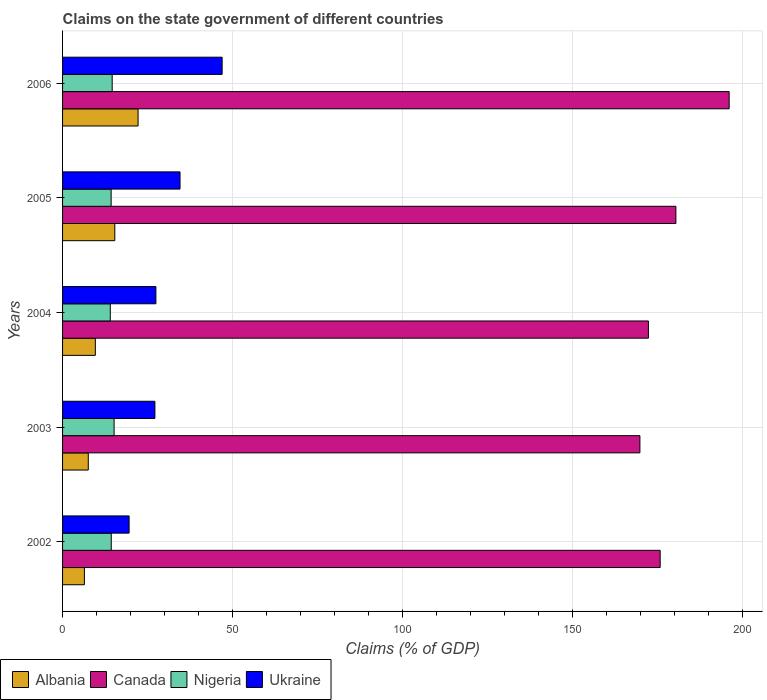How many different coloured bars are there?
Provide a short and direct response. 4. How many groups of bars are there?
Make the answer very short. 5. Are the number of bars on each tick of the Y-axis equal?
Give a very brief answer. Yes. How many bars are there on the 5th tick from the bottom?
Your answer should be very brief. 4. What is the percentage of GDP claimed on the state government in Nigeria in 2005?
Your answer should be compact. 14.28. Across all years, what is the maximum percentage of GDP claimed on the state government in Nigeria?
Provide a short and direct response. 15.15. Across all years, what is the minimum percentage of GDP claimed on the state government in Albania?
Offer a very short reply. 6.42. In which year was the percentage of GDP claimed on the state government in Nigeria minimum?
Offer a very short reply. 2004. What is the total percentage of GDP claimed on the state government in Albania in the graph?
Your answer should be compact. 61.2. What is the difference between the percentage of GDP claimed on the state government in Canada in 2005 and that in 2006?
Your answer should be compact. -15.67. What is the difference between the percentage of GDP claimed on the state government in Ukraine in 2006 and the percentage of GDP claimed on the state government in Nigeria in 2002?
Offer a terse response. 32.61. What is the average percentage of GDP claimed on the state government in Nigeria per year?
Keep it short and to the point. 14.48. In the year 2006, what is the difference between the percentage of GDP claimed on the state government in Canada and percentage of GDP claimed on the state government in Albania?
Ensure brevity in your answer.  173.85. What is the ratio of the percentage of GDP claimed on the state government in Canada in 2005 to that in 2006?
Offer a terse response. 0.92. Is the percentage of GDP claimed on the state government in Canada in 2004 less than that in 2006?
Offer a terse response. Yes. What is the difference between the highest and the second highest percentage of GDP claimed on the state government in Canada?
Ensure brevity in your answer.  15.67. What is the difference between the highest and the lowest percentage of GDP claimed on the state government in Ukraine?
Offer a terse response. 27.36. Is the sum of the percentage of GDP claimed on the state government in Ukraine in 2002 and 2003 greater than the maximum percentage of GDP claimed on the state government in Canada across all years?
Make the answer very short. No. What does the 2nd bar from the top in 2005 represents?
Give a very brief answer. Nigeria. What does the 1st bar from the bottom in 2006 represents?
Your answer should be very brief. Albania. How many bars are there?
Offer a terse response. 20. How many years are there in the graph?
Provide a short and direct response. 5. What is the difference between two consecutive major ticks on the X-axis?
Ensure brevity in your answer.  50. Are the values on the major ticks of X-axis written in scientific E-notation?
Your response must be concise. No. Does the graph contain grids?
Ensure brevity in your answer.  Yes. How many legend labels are there?
Your answer should be compact. 4. How are the legend labels stacked?
Your answer should be compact. Horizontal. What is the title of the graph?
Make the answer very short. Claims on the state government of different countries. What is the label or title of the X-axis?
Your answer should be very brief. Claims (% of GDP). What is the Claims (% of GDP) of Albania in 2002?
Offer a very short reply. 6.42. What is the Claims (% of GDP) in Canada in 2002?
Your response must be concise. 175.77. What is the Claims (% of GDP) in Nigeria in 2002?
Your answer should be very brief. 14.32. What is the Claims (% of GDP) in Ukraine in 2002?
Offer a very short reply. 19.57. What is the Claims (% of GDP) in Albania in 2003?
Keep it short and to the point. 7.56. What is the Claims (% of GDP) of Canada in 2003?
Keep it short and to the point. 169.81. What is the Claims (% of GDP) of Nigeria in 2003?
Provide a succinct answer. 15.15. What is the Claims (% of GDP) of Ukraine in 2003?
Offer a terse response. 27.16. What is the Claims (% of GDP) in Albania in 2004?
Your answer should be very brief. 9.64. What is the Claims (% of GDP) in Canada in 2004?
Ensure brevity in your answer.  172.31. What is the Claims (% of GDP) of Nigeria in 2004?
Ensure brevity in your answer.  14.03. What is the Claims (% of GDP) of Ukraine in 2004?
Provide a succinct answer. 27.45. What is the Claims (% of GDP) of Albania in 2005?
Provide a short and direct response. 15.36. What is the Claims (% of GDP) of Canada in 2005?
Make the answer very short. 180.39. What is the Claims (% of GDP) in Nigeria in 2005?
Offer a terse response. 14.28. What is the Claims (% of GDP) in Ukraine in 2005?
Offer a terse response. 34.55. What is the Claims (% of GDP) in Albania in 2006?
Provide a short and direct response. 22.21. What is the Claims (% of GDP) in Canada in 2006?
Provide a succinct answer. 196.06. What is the Claims (% of GDP) in Nigeria in 2006?
Keep it short and to the point. 14.59. What is the Claims (% of GDP) of Ukraine in 2006?
Provide a succinct answer. 46.93. Across all years, what is the maximum Claims (% of GDP) in Albania?
Make the answer very short. 22.21. Across all years, what is the maximum Claims (% of GDP) of Canada?
Make the answer very short. 196.06. Across all years, what is the maximum Claims (% of GDP) of Nigeria?
Offer a terse response. 15.15. Across all years, what is the maximum Claims (% of GDP) of Ukraine?
Provide a short and direct response. 46.93. Across all years, what is the minimum Claims (% of GDP) of Albania?
Provide a short and direct response. 6.42. Across all years, what is the minimum Claims (% of GDP) in Canada?
Your answer should be compact. 169.81. Across all years, what is the minimum Claims (% of GDP) of Nigeria?
Your response must be concise. 14.03. Across all years, what is the minimum Claims (% of GDP) of Ukraine?
Offer a very short reply. 19.57. What is the total Claims (% of GDP) in Albania in the graph?
Give a very brief answer. 61.2. What is the total Claims (% of GDP) of Canada in the graph?
Give a very brief answer. 894.34. What is the total Claims (% of GDP) in Nigeria in the graph?
Your response must be concise. 72.39. What is the total Claims (% of GDP) of Ukraine in the graph?
Make the answer very short. 155.67. What is the difference between the Claims (% of GDP) of Albania in 2002 and that in 2003?
Provide a succinct answer. -1.14. What is the difference between the Claims (% of GDP) of Canada in 2002 and that in 2003?
Offer a terse response. 5.96. What is the difference between the Claims (% of GDP) in Nigeria in 2002 and that in 2003?
Offer a terse response. -0.83. What is the difference between the Claims (% of GDP) in Ukraine in 2002 and that in 2003?
Provide a succinct answer. -7.59. What is the difference between the Claims (% of GDP) of Albania in 2002 and that in 2004?
Give a very brief answer. -3.21. What is the difference between the Claims (% of GDP) in Canada in 2002 and that in 2004?
Ensure brevity in your answer.  3.46. What is the difference between the Claims (% of GDP) of Nigeria in 2002 and that in 2004?
Give a very brief answer. 0.29. What is the difference between the Claims (% of GDP) of Ukraine in 2002 and that in 2004?
Provide a short and direct response. -7.88. What is the difference between the Claims (% of GDP) of Albania in 2002 and that in 2005?
Give a very brief answer. -8.94. What is the difference between the Claims (% of GDP) in Canada in 2002 and that in 2005?
Keep it short and to the point. -4.63. What is the difference between the Claims (% of GDP) of Nigeria in 2002 and that in 2005?
Ensure brevity in your answer.  0.04. What is the difference between the Claims (% of GDP) in Ukraine in 2002 and that in 2005?
Make the answer very short. -14.98. What is the difference between the Claims (% of GDP) in Albania in 2002 and that in 2006?
Offer a terse response. -15.79. What is the difference between the Claims (% of GDP) in Canada in 2002 and that in 2006?
Make the answer very short. -20.29. What is the difference between the Claims (% of GDP) in Nigeria in 2002 and that in 2006?
Your answer should be very brief. -0.27. What is the difference between the Claims (% of GDP) in Ukraine in 2002 and that in 2006?
Give a very brief answer. -27.36. What is the difference between the Claims (% of GDP) in Albania in 2003 and that in 2004?
Give a very brief answer. -2.08. What is the difference between the Claims (% of GDP) in Canada in 2003 and that in 2004?
Provide a succinct answer. -2.51. What is the difference between the Claims (% of GDP) in Nigeria in 2003 and that in 2004?
Your answer should be compact. 1.12. What is the difference between the Claims (% of GDP) of Ukraine in 2003 and that in 2004?
Offer a very short reply. -0.29. What is the difference between the Claims (% of GDP) in Albania in 2003 and that in 2005?
Provide a succinct answer. -7.8. What is the difference between the Claims (% of GDP) of Canada in 2003 and that in 2005?
Provide a succinct answer. -10.59. What is the difference between the Claims (% of GDP) of Nigeria in 2003 and that in 2005?
Offer a terse response. 0.87. What is the difference between the Claims (% of GDP) of Ukraine in 2003 and that in 2005?
Provide a short and direct response. -7.39. What is the difference between the Claims (% of GDP) of Albania in 2003 and that in 2006?
Provide a succinct answer. -14.65. What is the difference between the Claims (% of GDP) of Canada in 2003 and that in 2006?
Your answer should be compact. -26.25. What is the difference between the Claims (% of GDP) in Nigeria in 2003 and that in 2006?
Give a very brief answer. 0.56. What is the difference between the Claims (% of GDP) of Ukraine in 2003 and that in 2006?
Provide a succinct answer. -19.77. What is the difference between the Claims (% of GDP) in Albania in 2004 and that in 2005?
Your response must be concise. -5.72. What is the difference between the Claims (% of GDP) in Canada in 2004 and that in 2005?
Ensure brevity in your answer.  -8.08. What is the difference between the Claims (% of GDP) of Nigeria in 2004 and that in 2005?
Ensure brevity in your answer.  -0.25. What is the difference between the Claims (% of GDP) of Ukraine in 2004 and that in 2005?
Offer a very short reply. -7.1. What is the difference between the Claims (% of GDP) of Albania in 2004 and that in 2006?
Provide a succinct answer. -12.57. What is the difference between the Claims (% of GDP) of Canada in 2004 and that in 2006?
Your answer should be compact. -23.75. What is the difference between the Claims (% of GDP) of Nigeria in 2004 and that in 2006?
Ensure brevity in your answer.  -0.56. What is the difference between the Claims (% of GDP) in Ukraine in 2004 and that in 2006?
Provide a succinct answer. -19.48. What is the difference between the Claims (% of GDP) in Albania in 2005 and that in 2006?
Keep it short and to the point. -6.85. What is the difference between the Claims (% of GDP) of Canada in 2005 and that in 2006?
Provide a short and direct response. -15.67. What is the difference between the Claims (% of GDP) in Nigeria in 2005 and that in 2006?
Make the answer very short. -0.31. What is the difference between the Claims (% of GDP) of Ukraine in 2005 and that in 2006?
Offer a terse response. -12.38. What is the difference between the Claims (% of GDP) in Albania in 2002 and the Claims (% of GDP) in Canada in 2003?
Provide a succinct answer. -163.38. What is the difference between the Claims (% of GDP) of Albania in 2002 and the Claims (% of GDP) of Nigeria in 2003?
Give a very brief answer. -8.73. What is the difference between the Claims (% of GDP) of Albania in 2002 and the Claims (% of GDP) of Ukraine in 2003?
Your answer should be compact. -20.73. What is the difference between the Claims (% of GDP) in Canada in 2002 and the Claims (% of GDP) in Nigeria in 2003?
Your response must be concise. 160.61. What is the difference between the Claims (% of GDP) in Canada in 2002 and the Claims (% of GDP) in Ukraine in 2003?
Your answer should be compact. 148.61. What is the difference between the Claims (% of GDP) in Nigeria in 2002 and the Claims (% of GDP) in Ukraine in 2003?
Make the answer very short. -12.84. What is the difference between the Claims (% of GDP) of Albania in 2002 and the Claims (% of GDP) of Canada in 2004?
Give a very brief answer. -165.89. What is the difference between the Claims (% of GDP) of Albania in 2002 and the Claims (% of GDP) of Nigeria in 2004?
Offer a very short reply. -7.61. What is the difference between the Claims (% of GDP) in Albania in 2002 and the Claims (% of GDP) in Ukraine in 2004?
Ensure brevity in your answer.  -21.03. What is the difference between the Claims (% of GDP) of Canada in 2002 and the Claims (% of GDP) of Nigeria in 2004?
Give a very brief answer. 161.73. What is the difference between the Claims (% of GDP) of Canada in 2002 and the Claims (% of GDP) of Ukraine in 2004?
Offer a very short reply. 148.32. What is the difference between the Claims (% of GDP) of Nigeria in 2002 and the Claims (% of GDP) of Ukraine in 2004?
Offer a very short reply. -13.13. What is the difference between the Claims (% of GDP) in Albania in 2002 and the Claims (% of GDP) in Canada in 2005?
Your answer should be compact. -173.97. What is the difference between the Claims (% of GDP) of Albania in 2002 and the Claims (% of GDP) of Nigeria in 2005?
Provide a succinct answer. -7.86. What is the difference between the Claims (% of GDP) of Albania in 2002 and the Claims (% of GDP) of Ukraine in 2005?
Give a very brief answer. -28.13. What is the difference between the Claims (% of GDP) in Canada in 2002 and the Claims (% of GDP) in Nigeria in 2005?
Provide a succinct answer. 161.48. What is the difference between the Claims (% of GDP) in Canada in 2002 and the Claims (% of GDP) in Ukraine in 2005?
Provide a succinct answer. 141.22. What is the difference between the Claims (% of GDP) of Nigeria in 2002 and the Claims (% of GDP) of Ukraine in 2005?
Provide a succinct answer. -20.23. What is the difference between the Claims (% of GDP) of Albania in 2002 and the Claims (% of GDP) of Canada in 2006?
Offer a very short reply. -189.64. What is the difference between the Claims (% of GDP) in Albania in 2002 and the Claims (% of GDP) in Nigeria in 2006?
Offer a terse response. -8.17. What is the difference between the Claims (% of GDP) in Albania in 2002 and the Claims (% of GDP) in Ukraine in 2006?
Give a very brief answer. -40.51. What is the difference between the Claims (% of GDP) in Canada in 2002 and the Claims (% of GDP) in Nigeria in 2006?
Provide a succinct answer. 161.17. What is the difference between the Claims (% of GDP) in Canada in 2002 and the Claims (% of GDP) in Ukraine in 2006?
Your response must be concise. 128.83. What is the difference between the Claims (% of GDP) in Nigeria in 2002 and the Claims (% of GDP) in Ukraine in 2006?
Your answer should be compact. -32.61. What is the difference between the Claims (% of GDP) in Albania in 2003 and the Claims (% of GDP) in Canada in 2004?
Keep it short and to the point. -164.75. What is the difference between the Claims (% of GDP) in Albania in 2003 and the Claims (% of GDP) in Nigeria in 2004?
Your answer should be very brief. -6.47. What is the difference between the Claims (% of GDP) of Albania in 2003 and the Claims (% of GDP) of Ukraine in 2004?
Ensure brevity in your answer.  -19.89. What is the difference between the Claims (% of GDP) of Canada in 2003 and the Claims (% of GDP) of Nigeria in 2004?
Offer a terse response. 155.77. What is the difference between the Claims (% of GDP) of Canada in 2003 and the Claims (% of GDP) of Ukraine in 2004?
Make the answer very short. 142.35. What is the difference between the Claims (% of GDP) in Nigeria in 2003 and the Claims (% of GDP) in Ukraine in 2004?
Keep it short and to the point. -12.3. What is the difference between the Claims (% of GDP) in Albania in 2003 and the Claims (% of GDP) in Canada in 2005?
Ensure brevity in your answer.  -172.83. What is the difference between the Claims (% of GDP) in Albania in 2003 and the Claims (% of GDP) in Nigeria in 2005?
Provide a short and direct response. -6.72. What is the difference between the Claims (% of GDP) in Albania in 2003 and the Claims (% of GDP) in Ukraine in 2005?
Offer a very short reply. -26.99. What is the difference between the Claims (% of GDP) in Canada in 2003 and the Claims (% of GDP) in Nigeria in 2005?
Make the answer very short. 155.52. What is the difference between the Claims (% of GDP) of Canada in 2003 and the Claims (% of GDP) of Ukraine in 2005?
Give a very brief answer. 135.26. What is the difference between the Claims (% of GDP) of Nigeria in 2003 and the Claims (% of GDP) of Ukraine in 2005?
Offer a very short reply. -19.4. What is the difference between the Claims (% of GDP) of Albania in 2003 and the Claims (% of GDP) of Canada in 2006?
Your answer should be very brief. -188.5. What is the difference between the Claims (% of GDP) in Albania in 2003 and the Claims (% of GDP) in Nigeria in 2006?
Offer a terse response. -7.03. What is the difference between the Claims (% of GDP) in Albania in 2003 and the Claims (% of GDP) in Ukraine in 2006?
Your answer should be very brief. -39.37. What is the difference between the Claims (% of GDP) of Canada in 2003 and the Claims (% of GDP) of Nigeria in 2006?
Keep it short and to the point. 155.21. What is the difference between the Claims (% of GDP) of Canada in 2003 and the Claims (% of GDP) of Ukraine in 2006?
Ensure brevity in your answer.  122.87. What is the difference between the Claims (% of GDP) of Nigeria in 2003 and the Claims (% of GDP) of Ukraine in 2006?
Offer a very short reply. -31.78. What is the difference between the Claims (% of GDP) in Albania in 2004 and the Claims (% of GDP) in Canada in 2005?
Your answer should be very brief. -170.76. What is the difference between the Claims (% of GDP) in Albania in 2004 and the Claims (% of GDP) in Nigeria in 2005?
Ensure brevity in your answer.  -4.64. What is the difference between the Claims (% of GDP) in Albania in 2004 and the Claims (% of GDP) in Ukraine in 2005?
Make the answer very short. -24.91. What is the difference between the Claims (% of GDP) in Canada in 2004 and the Claims (% of GDP) in Nigeria in 2005?
Offer a very short reply. 158.03. What is the difference between the Claims (% of GDP) of Canada in 2004 and the Claims (% of GDP) of Ukraine in 2005?
Make the answer very short. 137.76. What is the difference between the Claims (% of GDP) in Nigeria in 2004 and the Claims (% of GDP) in Ukraine in 2005?
Your answer should be very brief. -20.52. What is the difference between the Claims (% of GDP) of Albania in 2004 and the Claims (% of GDP) of Canada in 2006?
Ensure brevity in your answer.  -186.42. What is the difference between the Claims (% of GDP) in Albania in 2004 and the Claims (% of GDP) in Nigeria in 2006?
Provide a short and direct response. -4.96. What is the difference between the Claims (% of GDP) of Albania in 2004 and the Claims (% of GDP) of Ukraine in 2006?
Offer a very short reply. -37.29. What is the difference between the Claims (% of GDP) of Canada in 2004 and the Claims (% of GDP) of Nigeria in 2006?
Provide a succinct answer. 157.72. What is the difference between the Claims (% of GDP) in Canada in 2004 and the Claims (% of GDP) in Ukraine in 2006?
Your answer should be very brief. 125.38. What is the difference between the Claims (% of GDP) in Nigeria in 2004 and the Claims (% of GDP) in Ukraine in 2006?
Your answer should be compact. -32.9. What is the difference between the Claims (% of GDP) in Albania in 2005 and the Claims (% of GDP) in Canada in 2006?
Offer a very short reply. -180.7. What is the difference between the Claims (% of GDP) of Albania in 2005 and the Claims (% of GDP) of Nigeria in 2006?
Provide a short and direct response. 0.77. What is the difference between the Claims (% of GDP) of Albania in 2005 and the Claims (% of GDP) of Ukraine in 2006?
Your response must be concise. -31.57. What is the difference between the Claims (% of GDP) in Canada in 2005 and the Claims (% of GDP) in Nigeria in 2006?
Keep it short and to the point. 165.8. What is the difference between the Claims (% of GDP) of Canada in 2005 and the Claims (% of GDP) of Ukraine in 2006?
Your answer should be compact. 133.46. What is the difference between the Claims (% of GDP) of Nigeria in 2005 and the Claims (% of GDP) of Ukraine in 2006?
Keep it short and to the point. -32.65. What is the average Claims (% of GDP) in Albania per year?
Ensure brevity in your answer.  12.24. What is the average Claims (% of GDP) in Canada per year?
Your answer should be very brief. 178.87. What is the average Claims (% of GDP) in Nigeria per year?
Keep it short and to the point. 14.48. What is the average Claims (% of GDP) of Ukraine per year?
Your answer should be very brief. 31.13. In the year 2002, what is the difference between the Claims (% of GDP) in Albania and Claims (% of GDP) in Canada?
Keep it short and to the point. -169.34. In the year 2002, what is the difference between the Claims (% of GDP) in Albania and Claims (% of GDP) in Nigeria?
Your response must be concise. -7.9. In the year 2002, what is the difference between the Claims (% of GDP) in Albania and Claims (% of GDP) in Ukraine?
Give a very brief answer. -13.15. In the year 2002, what is the difference between the Claims (% of GDP) of Canada and Claims (% of GDP) of Nigeria?
Offer a very short reply. 161.45. In the year 2002, what is the difference between the Claims (% of GDP) in Canada and Claims (% of GDP) in Ukraine?
Make the answer very short. 156.2. In the year 2002, what is the difference between the Claims (% of GDP) of Nigeria and Claims (% of GDP) of Ukraine?
Provide a succinct answer. -5.25. In the year 2003, what is the difference between the Claims (% of GDP) in Albania and Claims (% of GDP) in Canada?
Provide a succinct answer. -162.24. In the year 2003, what is the difference between the Claims (% of GDP) in Albania and Claims (% of GDP) in Nigeria?
Give a very brief answer. -7.59. In the year 2003, what is the difference between the Claims (% of GDP) in Albania and Claims (% of GDP) in Ukraine?
Your answer should be very brief. -19.6. In the year 2003, what is the difference between the Claims (% of GDP) of Canada and Claims (% of GDP) of Nigeria?
Your answer should be very brief. 154.65. In the year 2003, what is the difference between the Claims (% of GDP) of Canada and Claims (% of GDP) of Ukraine?
Provide a short and direct response. 142.65. In the year 2003, what is the difference between the Claims (% of GDP) of Nigeria and Claims (% of GDP) of Ukraine?
Provide a short and direct response. -12.01. In the year 2004, what is the difference between the Claims (% of GDP) of Albania and Claims (% of GDP) of Canada?
Provide a succinct answer. -162.67. In the year 2004, what is the difference between the Claims (% of GDP) of Albania and Claims (% of GDP) of Nigeria?
Your answer should be very brief. -4.4. In the year 2004, what is the difference between the Claims (% of GDP) in Albania and Claims (% of GDP) in Ukraine?
Provide a short and direct response. -17.81. In the year 2004, what is the difference between the Claims (% of GDP) in Canada and Claims (% of GDP) in Nigeria?
Your response must be concise. 158.28. In the year 2004, what is the difference between the Claims (% of GDP) of Canada and Claims (% of GDP) of Ukraine?
Your answer should be compact. 144.86. In the year 2004, what is the difference between the Claims (% of GDP) of Nigeria and Claims (% of GDP) of Ukraine?
Make the answer very short. -13.42. In the year 2005, what is the difference between the Claims (% of GDP) of Albania and Claims (% of GDP) of Canada?
Offer a terse response. -165.03. In the year 2005, what is the difference between the Claims (% of GDP) of Albania and Claims (% of GDP) of Nigeria?
Your response must be concise. 1.08. In the year 2005, what is the difference between the Claims (% of GDP) in Albania and Claims (% of GDP) in Ukraine?
Offer a very short reply. -19.19. In the year 2005, what is the difference between the Claims (% of GDP) in Canada and Claims (% of GDP) in Nigeria?
Ensure brevity in your answer.  166.11. In the year 2005, what is the difference between the Claims (% of GDP) of Canada and Claims (% of GDP) of Ukraine?
Keep it short and to the point. 145.84. In the year 2005, what is the difference between the Claims (% of GDP) in Nigeria and Claims (% of GDP) in Ukraine?
Your response must be concise. -20.27. In the year 2006, what is the difference between the Claims (% of GDP) of Albania and Claims (% of GDP) of Canada?
Offer a very short reply. -173.85. In the year 2006, what is the difference between the Claims (% of GDP) of Albania and Claims (% of GDP) of Nigeria?
Your answer should be compact. 7.62. In the year 2006, what is the difference between the Claims (% of GDP) in Albania and Claims (% of GDP) in Ukraine?
Offer a terse response. -24.72. In the year 2006, what is the difference between the Claims (% of GDP) of Canada and Claims (% of GDP) of Nigeria?
Keep it short and to the point. 181.47. In the year 2006, what is the difference between the Claims (% of GDP) of Canada and Claims (% of GDP) of Ukraine?
Keep it short and to the point. 149.13. In the year 2006, what is the difference between the Claims (% of GDP) in Nigeria and Claims (% of GDP) in Ukraine?
Offer a terse response. -32.34. What is the ratio of the Claims (% of GDP) in Albania in 2002 to that in 2003?
Your response must be concise. 0.85. What is the ratio of the Claims (% of GDP) of Canada in 2002 to that in 2003?
Provide a succinct answer. 1.04. What is the ratio of the Claims (% of GDP) of Nigeria in 2002 to that in 2003?
Provide a succinct answer. 0.94. What is the ratio of the Claims (% of GDP) of Ukraine in 2002 to that in 2003?
Ensure brevity in your answer.  0.72. What is the ratio of the Claims (% of GDP) of Albania in 2002 to that in 2004?
Offer a terse response. 0.67. What is the ratio of the Claims (% of GDP) in Canada in 2002 to that in 2004?
Give a very brief answer. 1.02. What is the ratio of the Claims (% of GDP) of Nigeria in 2002 to that in 2004?
Make the answer very short. 1.02. What is the ratio of the Claims (% of GDP) in Ukraine in 2002 to that in 2004?
Offer a very short reply. 0.71. What is the ratio of the Claims (% of GDP) in Albania in 2002 to that in 2005?
Your answer should be compact. 0.42. What is the ratio of the Claims (% of GDP) in Canada in 2002 to that in 2005?
Make the answer very short. 0.97. What is the ratio of the Claims (% of GDP) of Nigeria in 2002 to that in 2005?
Ensure brevity in your answer.  1. What is the ratio of the Claims (% of GDP) of Ukraine in 2002 to that in 2005?
Your response must be concise. 0.57. What is the ratio of the Claims (% of GDP) of Albania in 2002 to that in 2006?
Offer a very short reply. 0.29. What is the ratio of the Claims (% of GDP) of Canada in 2002 to that in 2006?
Provide a short and direct response. 0.9. What is the ratio of the Claims (% of GDP) in Nigeria in 2002 to that in 2006?
Offer a terse response. 0.98. What is the ratio of the Claims (% of GDP) in Ukraine in 2002 to that in 2006?
Keep it short and to the point. 0.42. What is the ratio of the Claims (% of GDP) in Albania in 2003 to that in 2004?
Ensure brevity in your answer.  0.78. What is the ratio of the Claims (% of GDP) in Canada in 2003 to that in 2004?
Offer a very short reply. 0.99. What is the ratio of the Claims (% of GDP) of Nigeria in 2003 to that in 2004?
Keep it short and to the point. 1.08. What is the ratio of the Claims (% of GDP) in Ukraine in 2003 to that in 2004?
Keep it short and to the point. 0.99. What is the ratio of the Claims (% of GDP) of Albania in 2003 to that in 2005?
Your answer should be very brief. 0.49. What is the ratio of the Claims (% of GDP) of Canada in 2003 to that in 2005?
Your response must be concise. 0.94. What is the ratio of the Claims (% of GDP) of Nigeria in 2003 to that in 2005?
Give a very brief answer. 1.06. What is the ratio of the Claims (% of GDP) in Ukraine in 2003 to that in 2005?
Provide a short and direct response. 0.79. What is the ratio of the Claims (% of GDP) of Albania in 2003 to that in 2006?
Make the answer very short. 0.34. What is the ratio of the Claims (% of GDP) of Canada in 2003 to that in 2006?
Keep it short and to the point. 0.87. What is the ratio of the Claims (% of GDP) in Nigeria in 2003 to that in 2006?
Provide a succinct answer. 1.04. What is the ratio of the Claims (% of GDP) of Ukraine in 2003 to that in 2006?
Offer a terse response. 0.58. What is the ratio of the Claims (% of GDP) in Albania in 2004 to that in 2005?
Your answer should be compact. 0.63. What is the ratio of the Claims (% of GDP) of Canada in 2004 to that in 2005?
Your answer should be compact. 0.96. What is the ratio of the Claims (% of GDP) of Nigeria in 2004 to that in 2005?
Keep it short and to the point. 0.98. What is the ratio of the Claims (% of GDP) in Ukraine in 2004 to that in 2005?
Your answer should be very brief. 0.79. What is the ratio of the Claims (% of GDP) of Albania in 2004 to that in 2006?
Offer a terse response. 0.43. What is the ratio of the Claims (% of GDP) in Canada in 2004 to that in 2006?
Offer a very short reply. 0.88. What is the ratio of the Claims (% of GDP) of Nigeria in 2004 to that in 2006?
Your response must be concise. 0.96. What is the ratio of the Claims (% of GDP) in Ukraine in 2004 to that in 2006?
Keep it short and to the point. 0.58. What is the ratio of the Claims (% of GDP) of Albania in 2005 to that in 2006?
Provide a short and direct response. 0.69. What is the ratio of the Claims (% of GDP) in Canada in 2005 to that in 2006?
Keep it short and to the point. 0.92. What is the ratio of the Claims (% of GDP) of Nigeria in 2005 to that in 2006?
Your response must be concise. 0.98. What is the ratio of the Claims (% of GDP) in Ukraine in 2005 to that in 2006?
Ensure brevity in your answer.  0.74. What is the difference between the highest and the second highest Claims (% of GDP) in Albania?
Keep it short and to the point. 6.85. What is the difference between the highest and the second highest Claims (% of GDP) of Canada?
Provide a short and direct response. 15.67. What is the difference between the highest and the second highest Claims (% of GDP) in Nigeria?
Offer a terse response. 0.56. What is the difference between the highest and the second highest Claims (% of GDP) of Ukraine?
Provide a short and direct response. 12.38. What is the difference between the highest and the lowest Claims (% of GDP) in Albania?
Provide a short and direct response. 15.79. What is the difference between the highest and the lowest Claims (% of GDP) of Canada?
Offer a very short reply. 26.25. What is the difference between the highest and the lowest Claims (% of GDP) of Nigeria?
Offer a very short reply. 1.12. What is the difference between the highest and the lowest Claims (% of GDP) in Ukraine?
Offer a terse response. 27.36. 